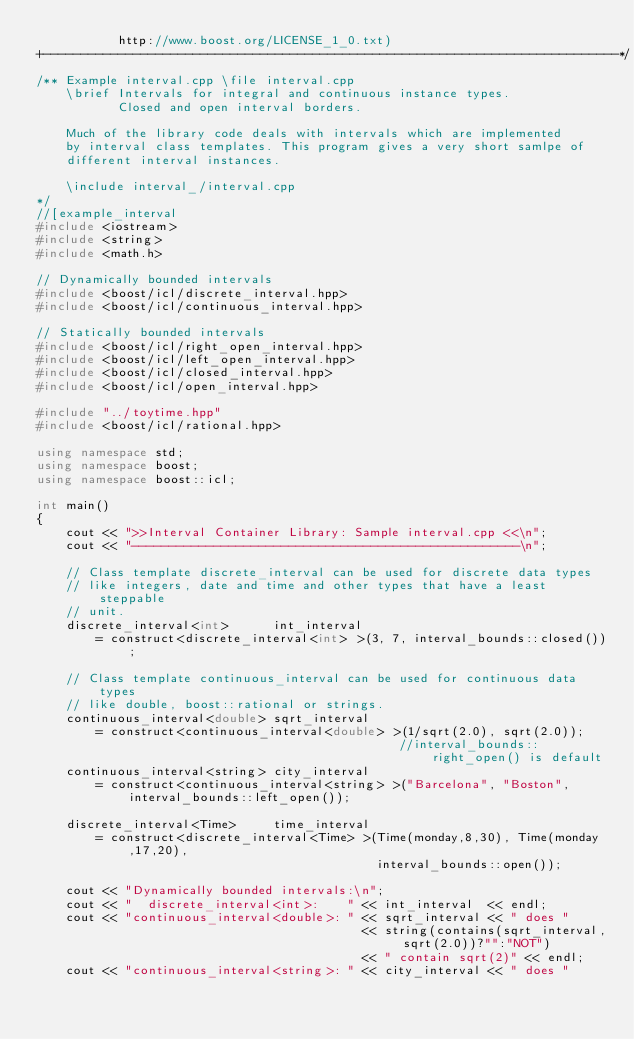Convert code to text. <code><loc_0><loc_0><loc_500><loc_500><_C++_>           http://www.boost.org/LICENSE_1_0.txt)
+-----------------------------------------------------------------------------*/
/** Example interval.cpp \file interval.cpp
    \brief Intervals for integral and continuous instance types.
           Closed and open interval borders.

    Much of the library code deals with intervals which are implemented
    by interval class templates. This program gives a very short samlpe of
    different interval instances.

    \include interval_/interval.cpp
*/
//[example_interval
#include <iostream>
#include <string>
#include <math.h>

// Dynamically bounded intervals
#include <boost/icl/discrete_interval.hpp>
#include <boost/icl/continuous_interval.hpp>

// Statically bounded intervals
#include <boost/icl/right_open_interval.hpp>
#include <boost/icl/left_open_interval.hpp>
#include <boost/icl/closed_interval.hpp>
#include <boost/icl/open_interval.hpp>

#include "../toytime.hpp"
#include <boost/icl/rational.hpp>

using namespace std;
using namespace boost;
using namespace boost::icl;

int main()
{
    cout << ">>Interval Container Library: Sample interval.cpp <<\n";
    cout << "----------------------------------------------------\n";

    // Class template discrete_interval can be used for discrete data types
    // like integers, date and time and other types that have a least steppable
    // unit.
    discrete_interval<int>      int_interval
        = construct<discrete_interval<int> >(3, 7, interval_bounds::closed());

    // Class template continuous_interval can be used for continuous data types
    // like double, boost::rational or strings.
    continuous_interval<double> sqrt_interval
        = construct<continuous_interval<double> >(1/sqrt(2.0), sqrt(2.0));
                                                 //interval_bounds::right_open() is default
    continuous_interval<string> city_interval
        = construct<continuous_interval<string> >("Barcelona", "Boston", interval_bounds::left_open());

    discrete_interval<Time>     time_interval
        = construct<discrete_interval<Time> >(Time(monday,8,30), Time(monday,17,20),
                                              interval_bounds::open());

    cout << "Dynamically bounded intervals:\n";
    cout << "  discrete_interval<int>:    " << int_interval  << endl;
    cout << "continuous_interval<double>: " << sqrt_interval << " does "
                                            << string(contains(sqrt_interval, sqrt(2.0))?"":"NOT")
                                            << " contain sqrt(2)" << endl;
    cout << "continuous_interval<string>: " << city_interval << " does "</code> 